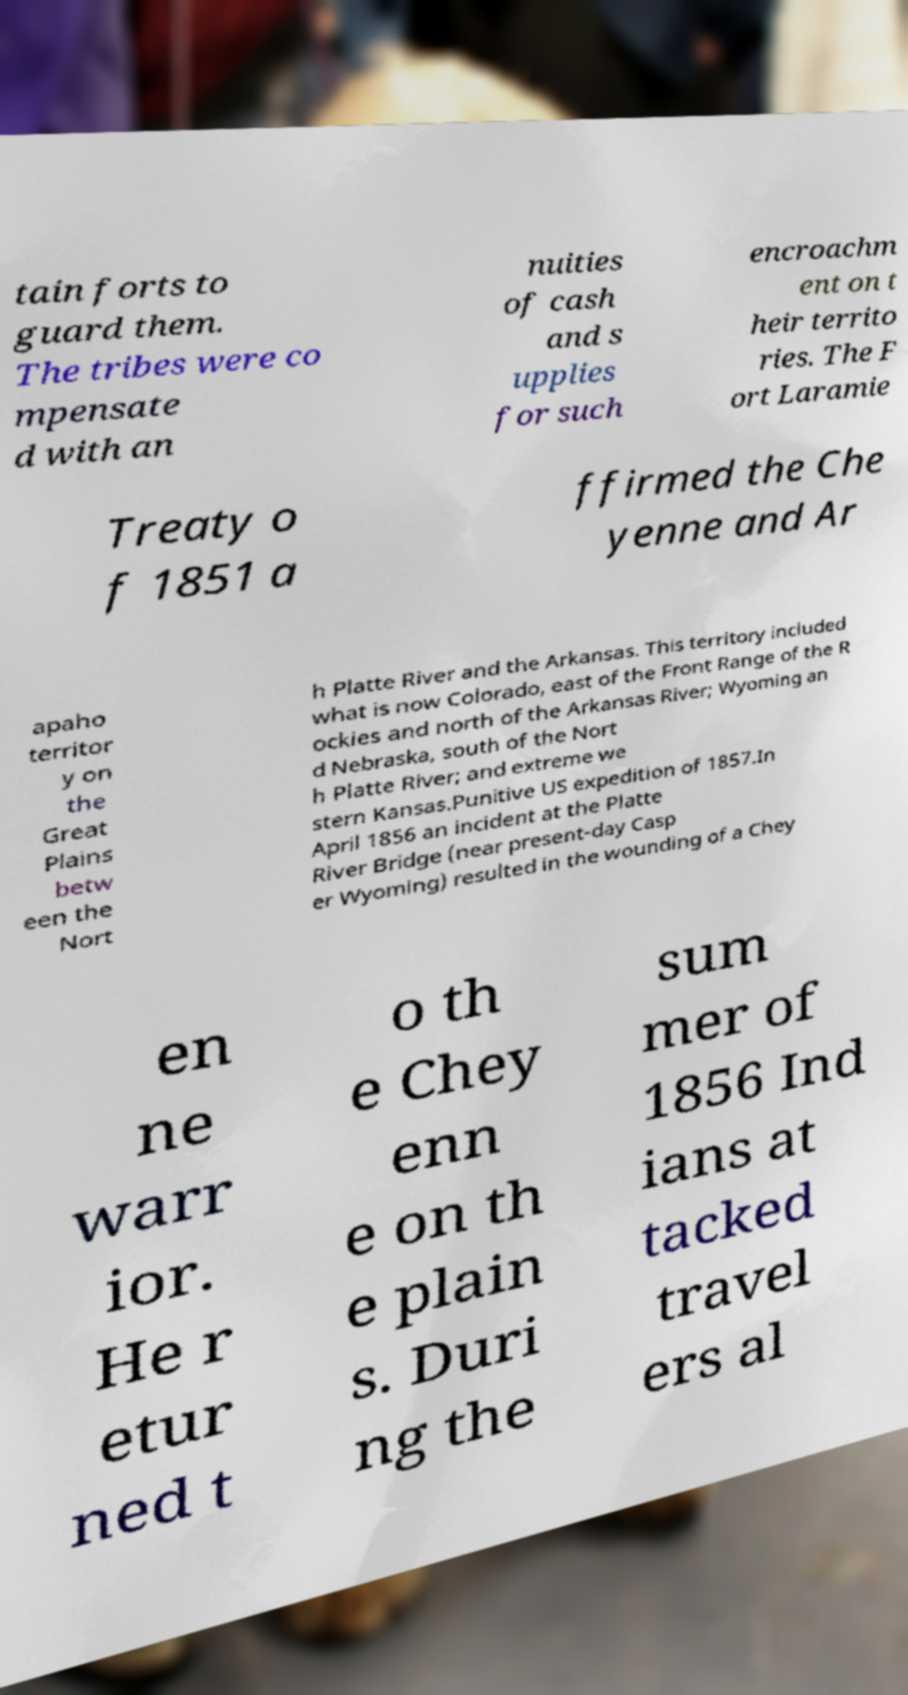Could you assist in decoding the text presented in this image and type it out clearly? tain forts to guard them. The tribes were co mpensate d with an nuities of cash and s upplies for such encroachm ent on t heir territo ries. The F ort Laramie Treaty o f 1851 a ffirmed the Che yenne and Ar apaho territor y on the Great Plains betw een the Nort h Platte River and the Arkansas. This territory included what is now Colorado, east of the Front Range of the R ockies and north of the Arkansas River; Wyoming an d Nebraska, south of the Nort h Platte River; and extreme we stern Kansas.Punitive US expedition of 1857.In April 1856 an incident at the Platte River Bridge (near present-day Casp er Wyoming) resulted in the wounding of a Chey en ne warr ior. He r etur ned t o th e Chey enn e on th e plain s. Duri ng the sum mer of 1856 Ind ians at tacked travel ers al 